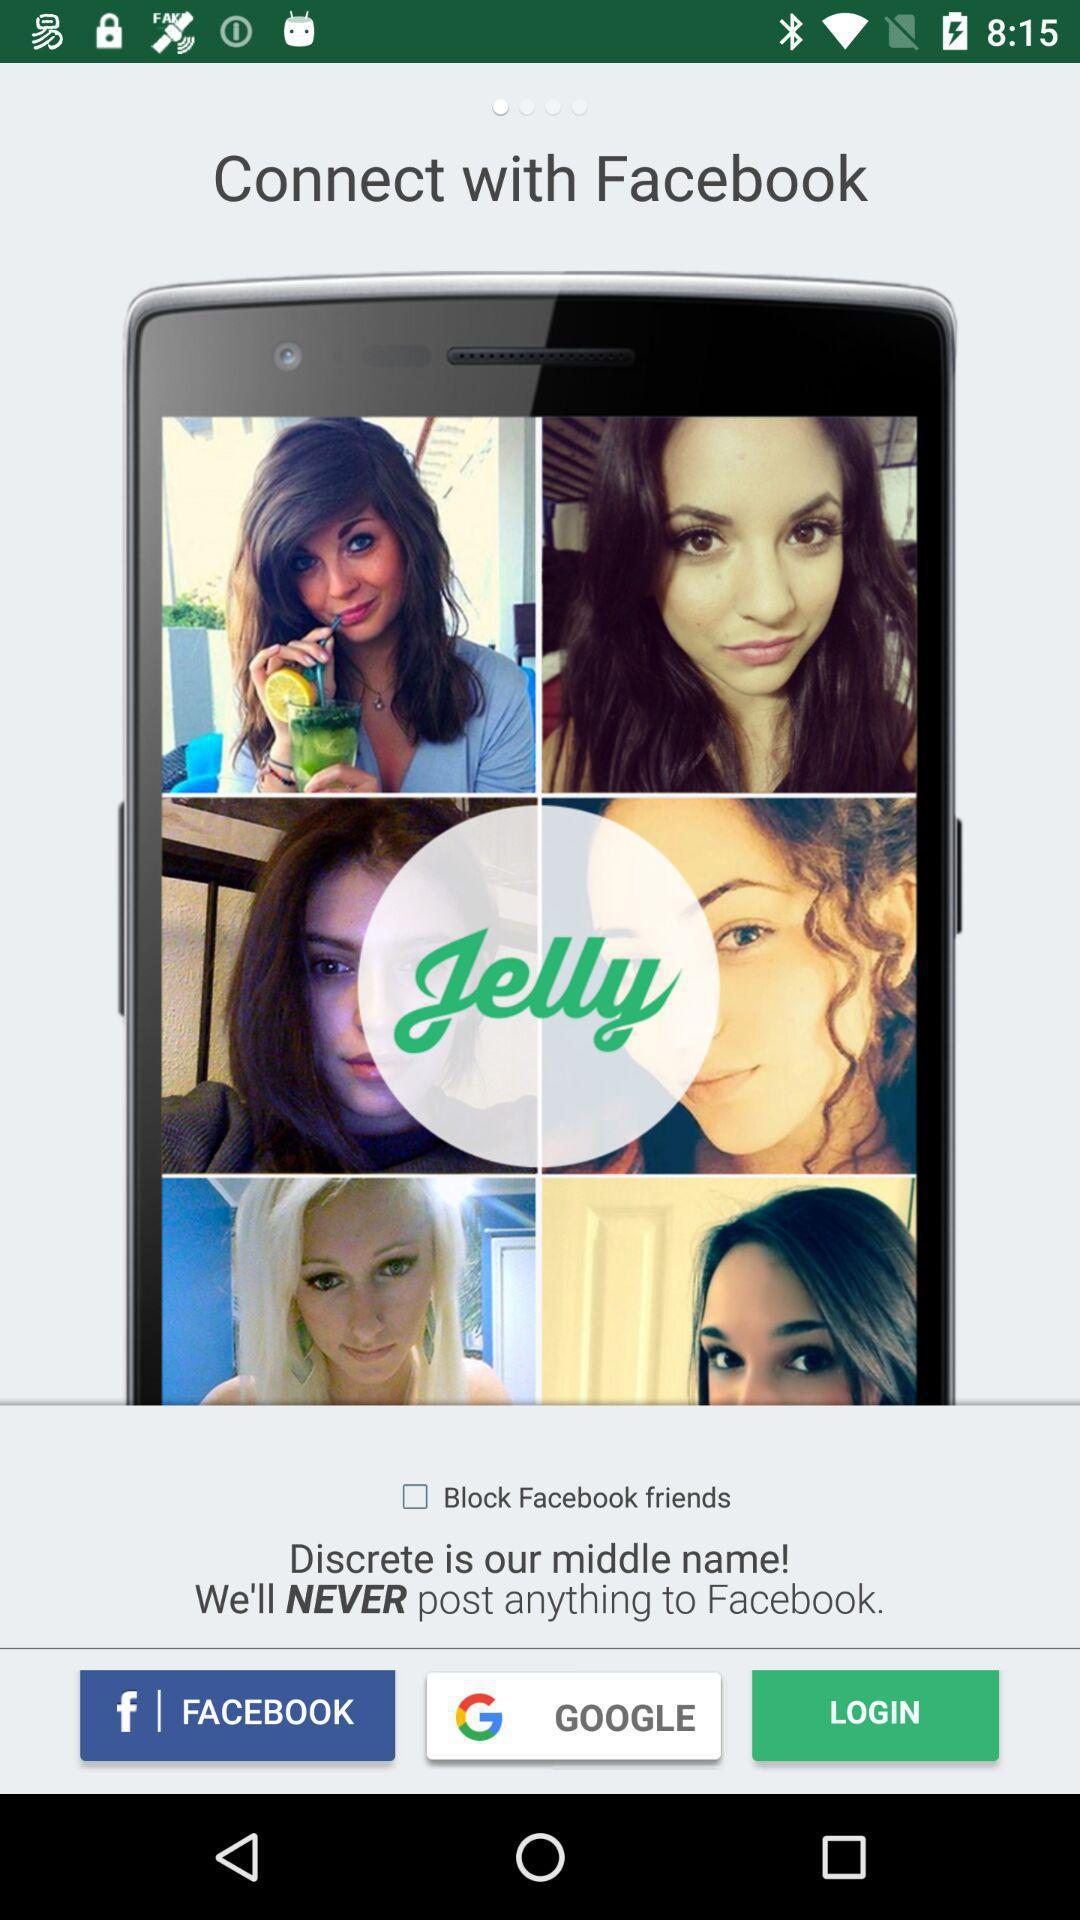What's the status of blocking Facebook friends? The status is off. 